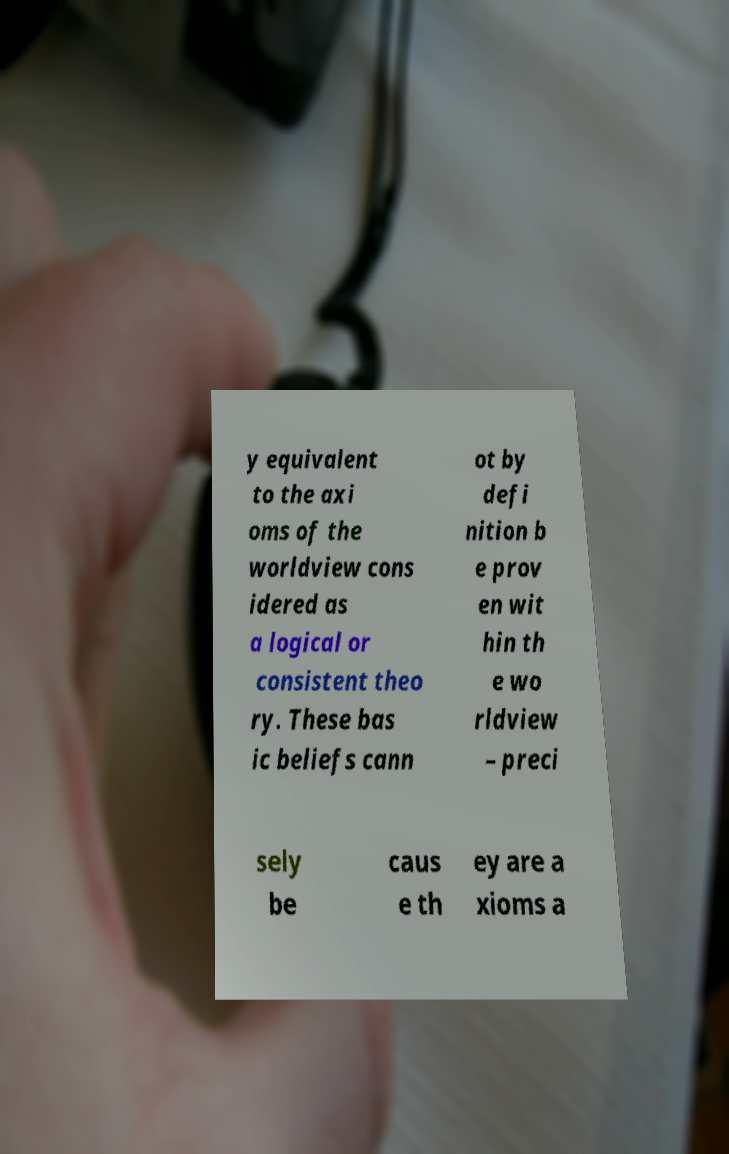Please read and relay the text visible in this image. What does it say? y equivalent to the axi oms of the worldview cons idered as a logical or consistent theo ry. These bas ic beliefs cann ot by defi nition b e prov en wit hin th e wo rldview – preci sely be caus e th ey are a xioms a 